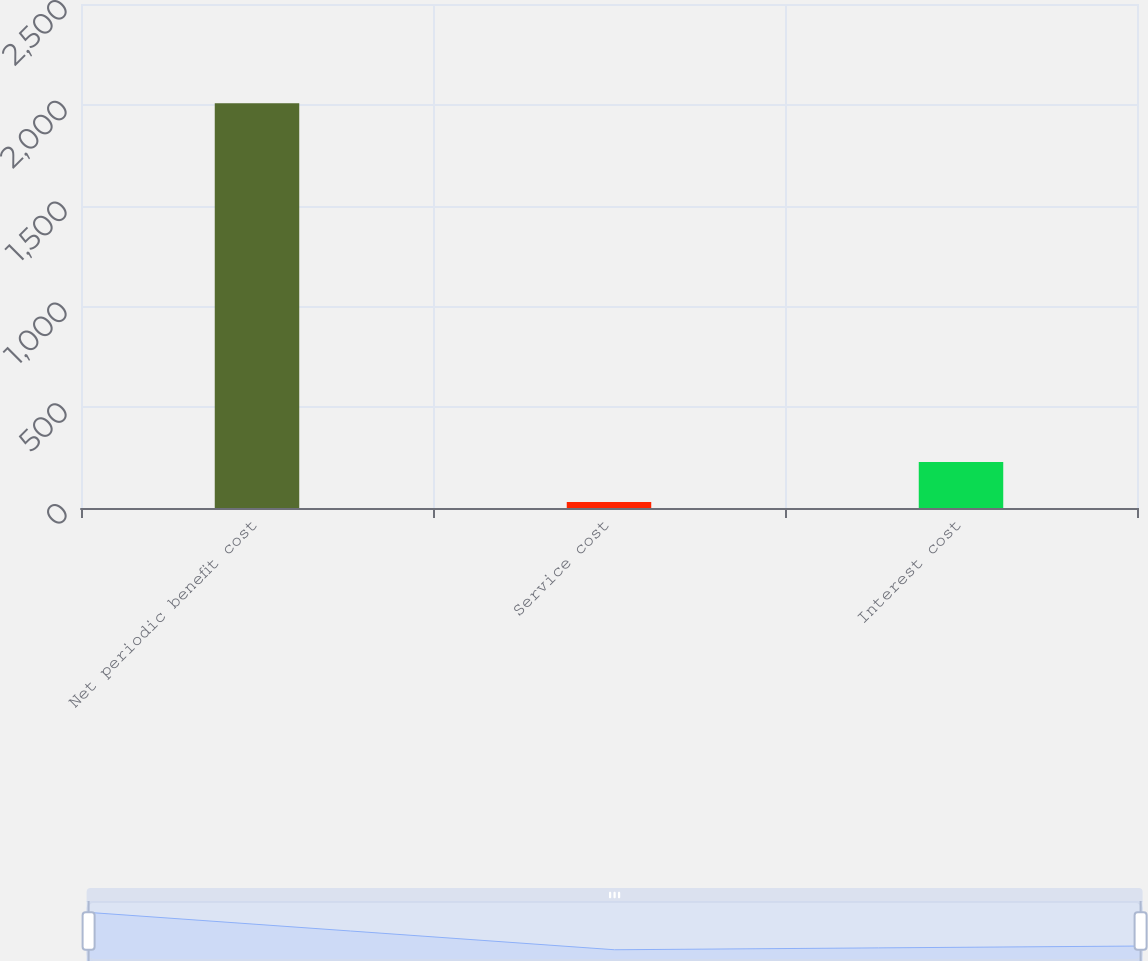Convert chart to OTSL. <chart><loc_0><loc_0><loc_500><loc_500><bar_chart><fcel>Net periodic benefit cost<fcel>Service cost<fcel>Interest cost<nl><fcel>2008<fcel>30<fcel>227.8<nl></chart> 